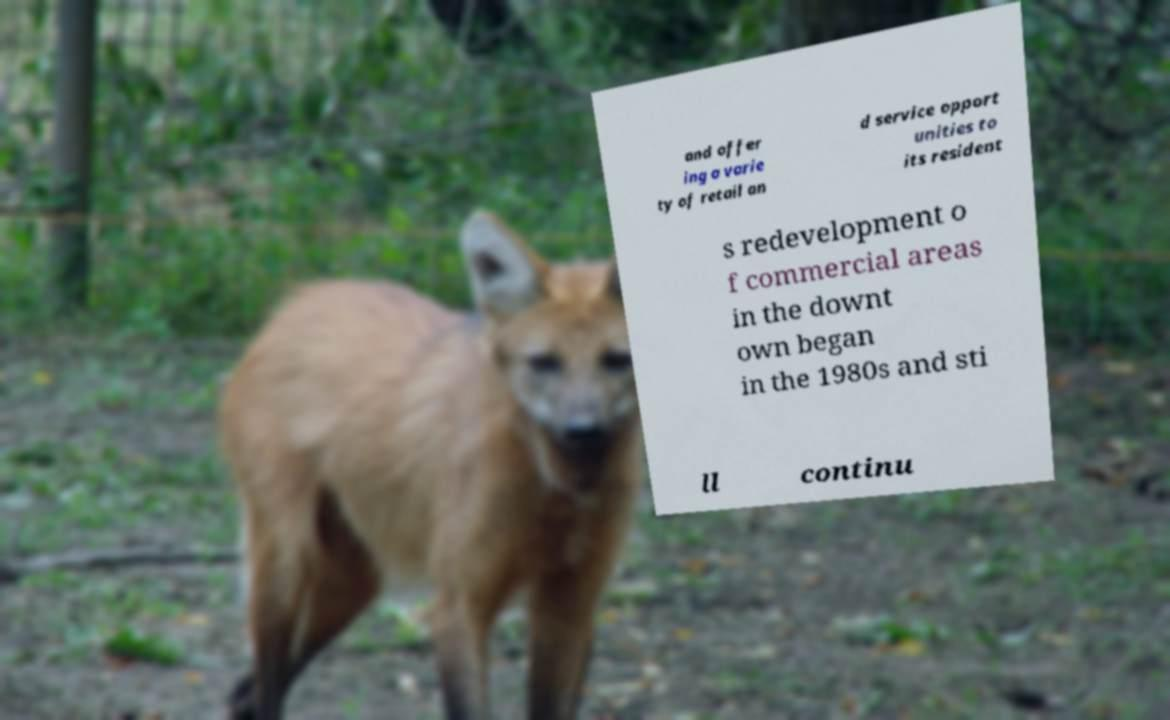Could you extract and type out the text from this image? and offer ing a varie ty of retail an d service opport unities to its resident s redevelopment o f commercial areas in the downt own began in the 1980s and sti ll continu 